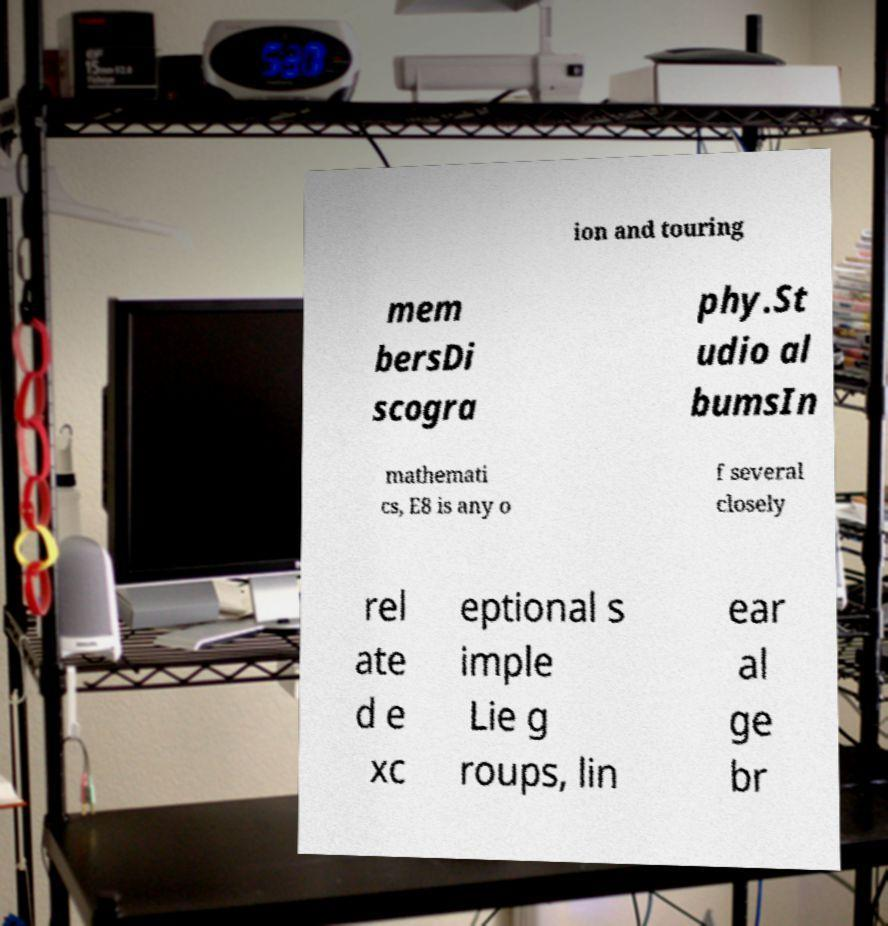Please identify and transcribe the text found in this image. ion and touring mem bersDi scogra phy.St udio al bumsIn mathemati cs, E8 is any o f several closely rel ate d e xc eptional s imple Lie g roups, lin ear al ge br 